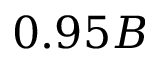Convert formula to latex. <formula><loc_0><loc_0><loc_500><loc_500>0 . 9 5 B</formula> 